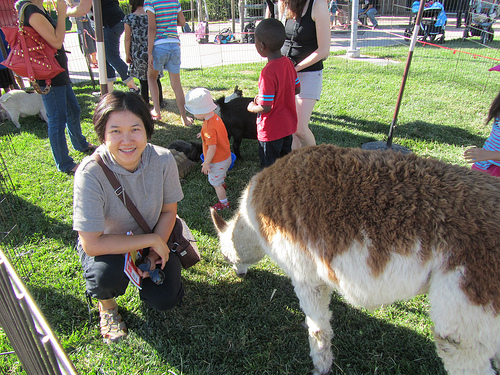Please provide the bounding box coordinate of the region this sentence describes: black sunglasses in the womans hand. The bounding box coordinates for the black sunglasses in the woman's hand are [0.26, 0.63, 0.34, 0.7]. 